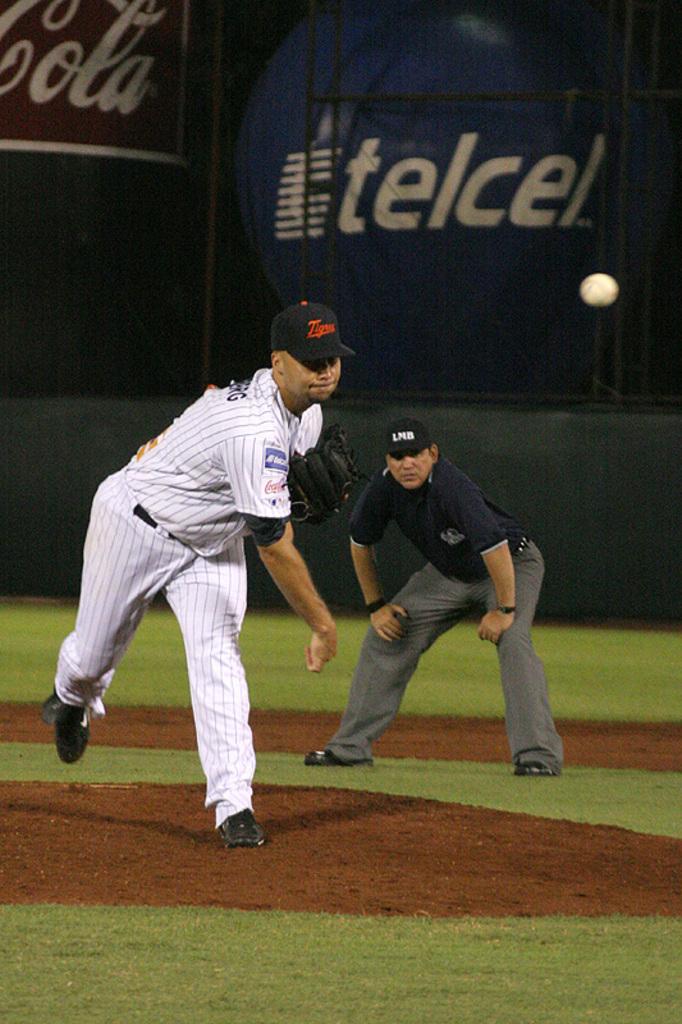What is one of the team sponsors?
Give a very brief answer. Telcel. What soft drink is a sponsor?
Make the answer very short. Coca cola. 